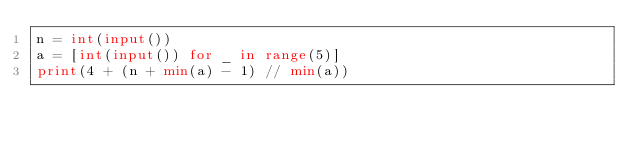<code> <loc_0><loc_0><loc_500><loc_500><_Python_>n = int(input())
a = [int(input()) for _ in range(5)]
print(4 + (n + min(a) - 1) // min(a))
</code> 